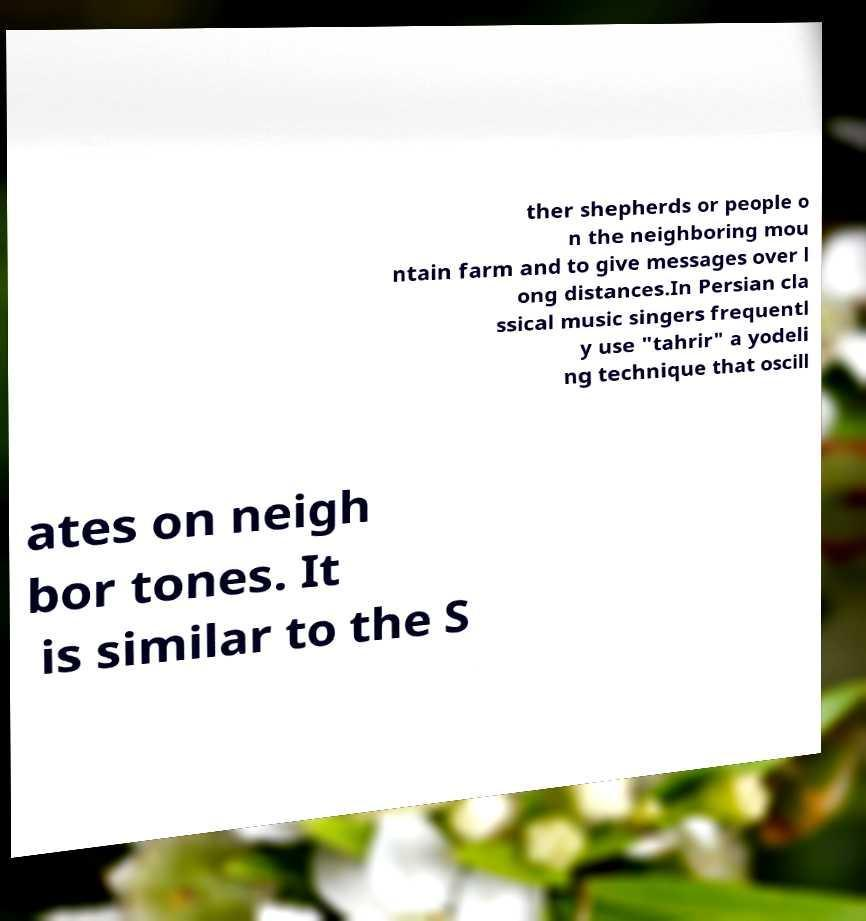Could you extract and type out the text from this image? ther shepherds or people o n the neighboring mou ntain farm and to give messages over l ong distances.In Persian cla ssical music singers frequentl y use "tahrir" a yodeli ng technique that oscill ates on neigh bor tones. It is similar to the S 